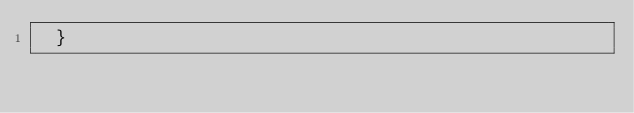<code> <loc_0><loc_0><loc_500><loc_500><_JavaScript_>  }</code> 